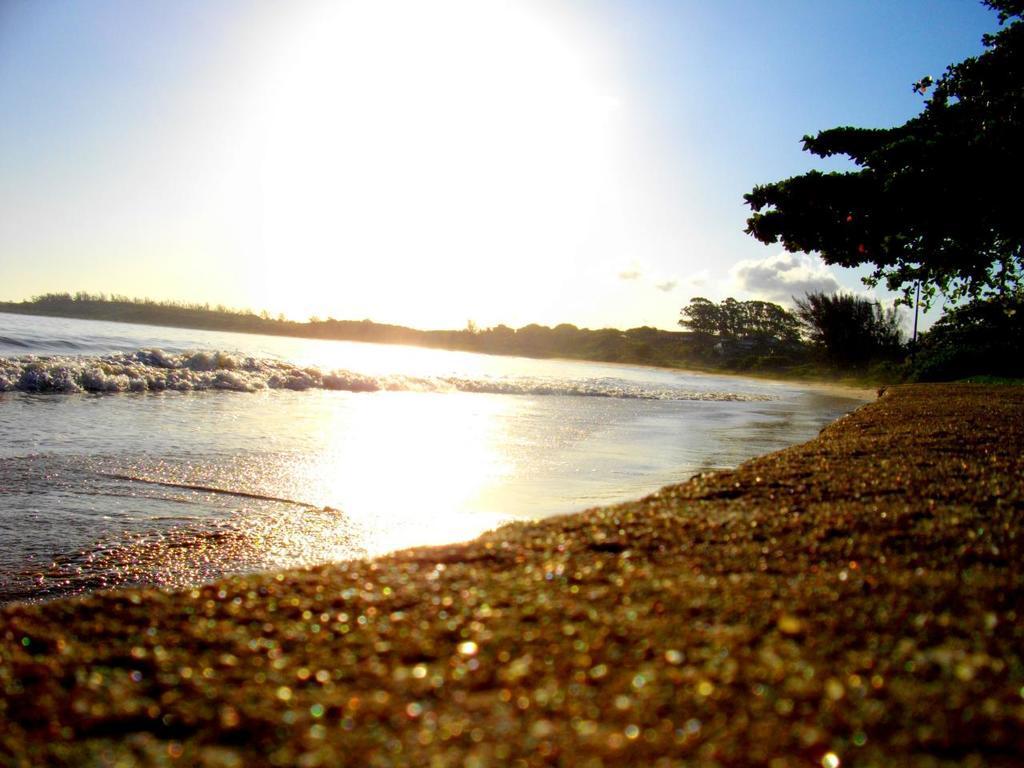In one or two sentences, can you explain what this image depicts? In the image we can see the water, sand and it looks like the beach. We can even see there are trees, plants and the sky. 